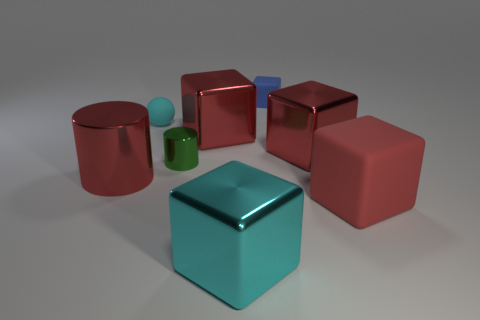What number of large cylinders are right of the matte object that is to the right of the blue matte thing?
Your response must be concise. 0. There is a sphere that is the same size as the blue block; what material is it?
Your answer should be compact. Rubber. Is the shape of the large metallic object that is on the left side of the green metallic object the same as  the big matte thing?
Make the answer very short. No. Are there more large red shiny cubes to the left of the cyan block than tiny matte spheres that are behind the cyan sphere?
Provide a succinct answer. Yes. What number of cyan blocks are made of the same material as the small blue block?
Your answer should be compact. 0. Do the green metallic object and the cyan metal thing have the same size?
Provide a succinct answer. No. What is the color of the small cylinder?
Offer a terse response. Green. What number of objects are large red metal cylinders or purple blocks?
Your answer should be compact. 1. Is there a red metallic thing of the same shape as the small blue object?
Offer a very short reply. Yes. Is the color of the cylinder that is to the left of the small green metallic thing the same as the big matte thing?
Offer a terse response. Yes. 